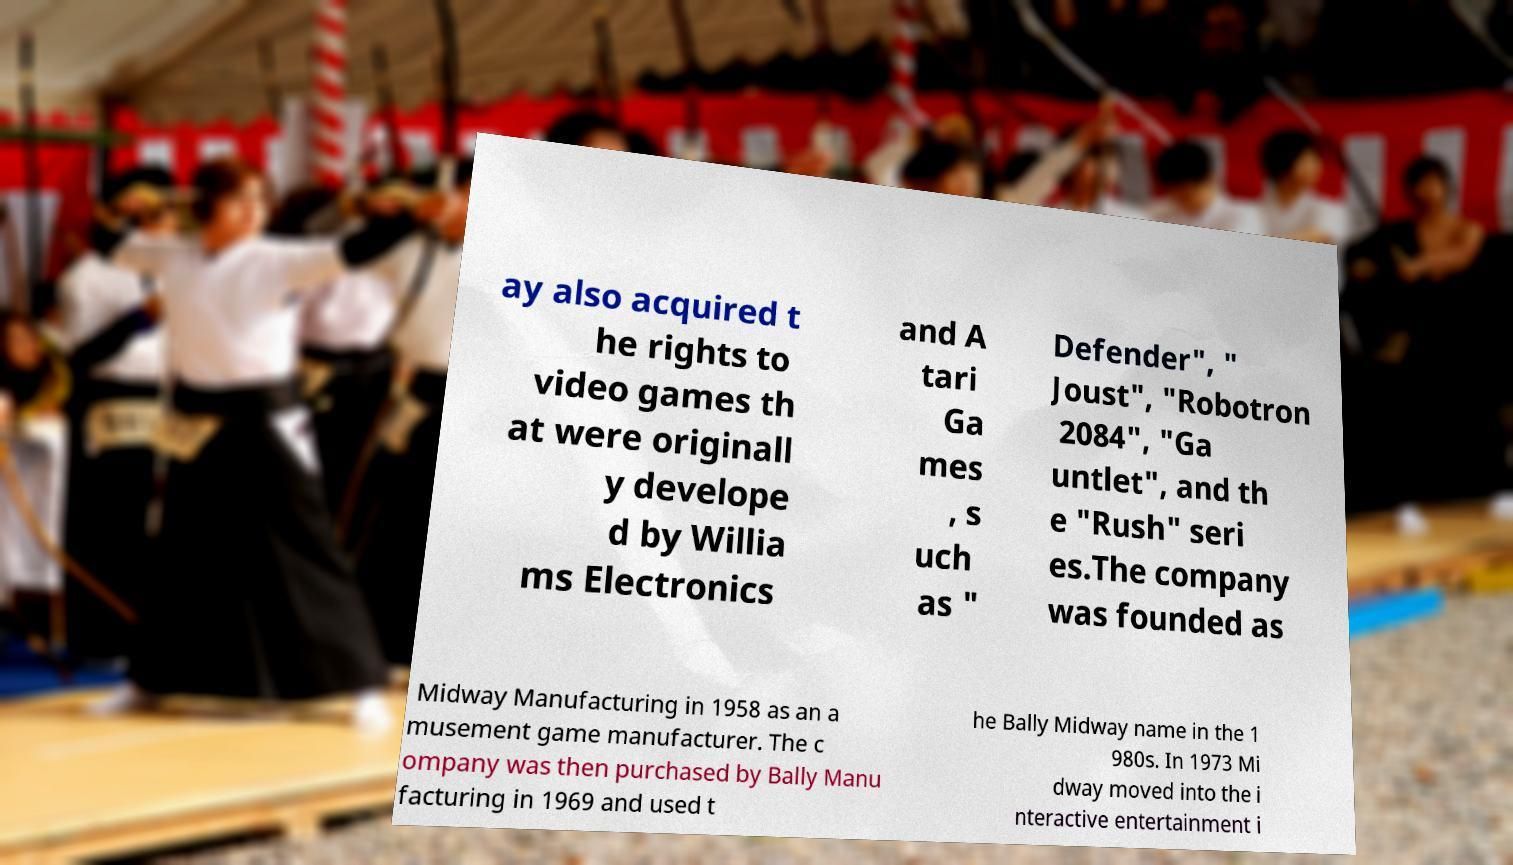Can you accurately transcribe the text from the provided image for me? ay also acquired t he rights to video games th at were originall y develope d by Willia ms Electronics and A tari Ga mes , s uch as " Defender", " Joust", "Robotron 2084", "Ga untlet", and th e "Rush" seri es.The company was founded as Midway Manufacturing in 1958 as an a musement game manufacturer. The c ompany was then purchased by Bally Manu facturing in 1969 and used t he Bally Midway name in the 1 980s. In 1973 Mi dway moved into the i nteractive entertainment i 